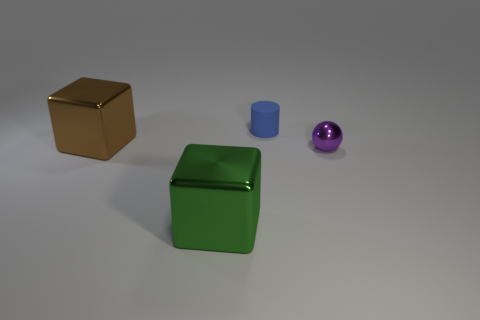What material is the big block that is in front of the purple metallic ball?
Provide a short and direct response. Metal. Is there another metallic block that has the same size as the brown metallic block?
Offer a terse response. Yes. What is the shape of the tiny blue matte thing?
Keep it short and to the point. Cylinder. Are there more spheres that are to the right of the blue matte thing than blue matte things that are in front of the big brown metallic block?
Provide a succinct answer. Yes. There is a metal object right of the matte thing; is its color the same as the big metal object in front of the small purple metal ball?
Your answer should be very brief. No. What is the shape of the object that is the same size as the cylinder?
Your response must be concise. Sphere. Are there any other objects of the same shape as the matte object?
Keep it short and to the point. No. Is the material of the thing that is on the right side of the small rubber cylinder the same as the small thing that is behind the small sphere?
Provide a succinct answer. No. What number of tiny objects have the same material as the big green cube?
Ensure brevity in your answer.  1. What is the color of the rubber object?
Your answer should be very brief. Blue. 